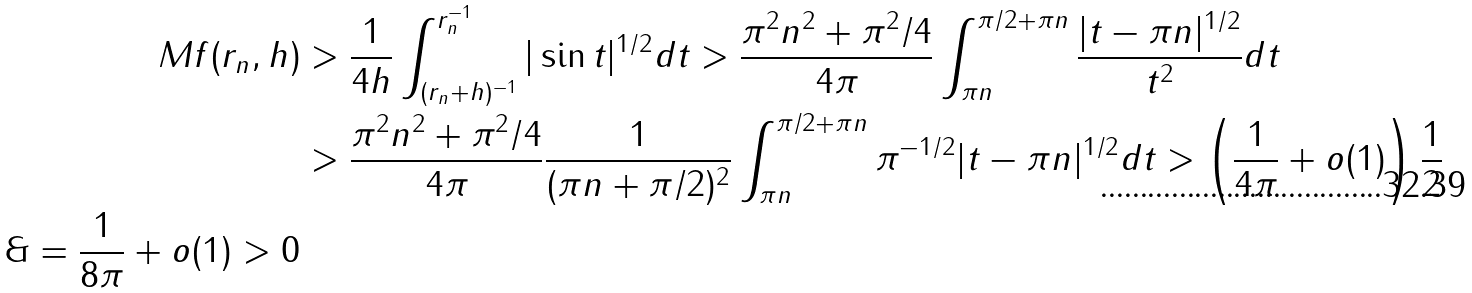Convert formula to latex. <formula><loc_0><loc_0><loc_500><loc_500>M f ( r _ { n } , h ) & > \frac { 1 } { 4 h } \int _ { ( r _ { n } + h ) ^ { - 1 } } ^ { r _ { n } ^ { - 1 } } | \sin t | ^ { 1 / 2 } d t > \frac { \pi ^ { 2 } n ^ { 2 } + \pi ^ { 2 } / 4 } { 4 \pi } \int _ { \pi n } ^ { \pi / 2 + \pi n } \frac { | t - \pi n | ^ { 1 / 2 } } { t ^ { 2 } } d t \\ & > \frac { \pi ^ { 2 } n ^ { 2 } + \pi ^ { 2 } / 4 } { 4 \pi } \frac { 1 } { ( \pi n + \pi / 2 ) ^ { 2 } } \int _ { \pi n } ^ { \pi / 2 + \pi n } \pi ^ { - 1 / 2 } | t - \pi n | ^ { 1 / 2 } d t > \left ( \frac { 1 } { 4 \pi } + o ( 1 ) \right ) \frac { 1 } { 2 } \\ \& = \frac { 1 } { 8 \pi } + o ( 1 ) > 0</formula> 